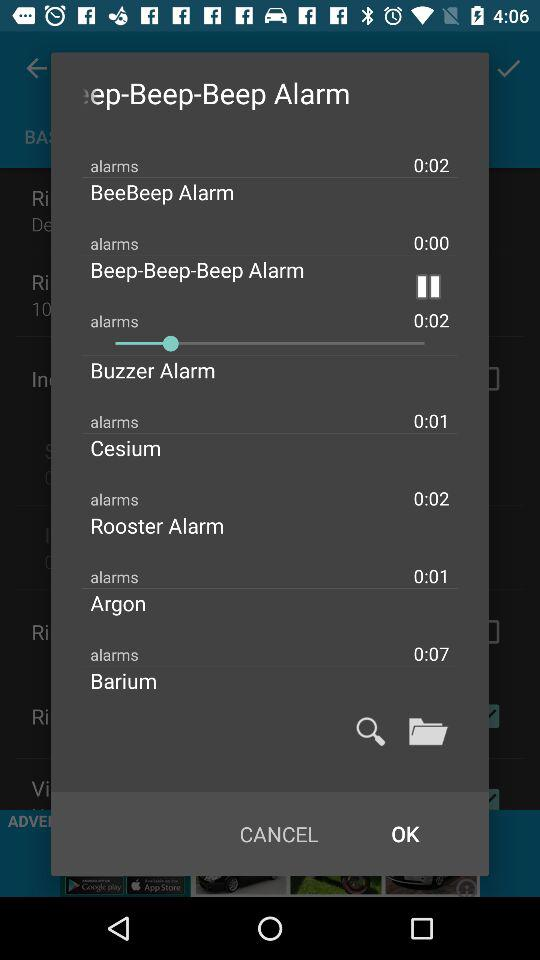Which alarm is the default alarm?
When the provided information is insufficient, respond with <no answer>. <no answer> 